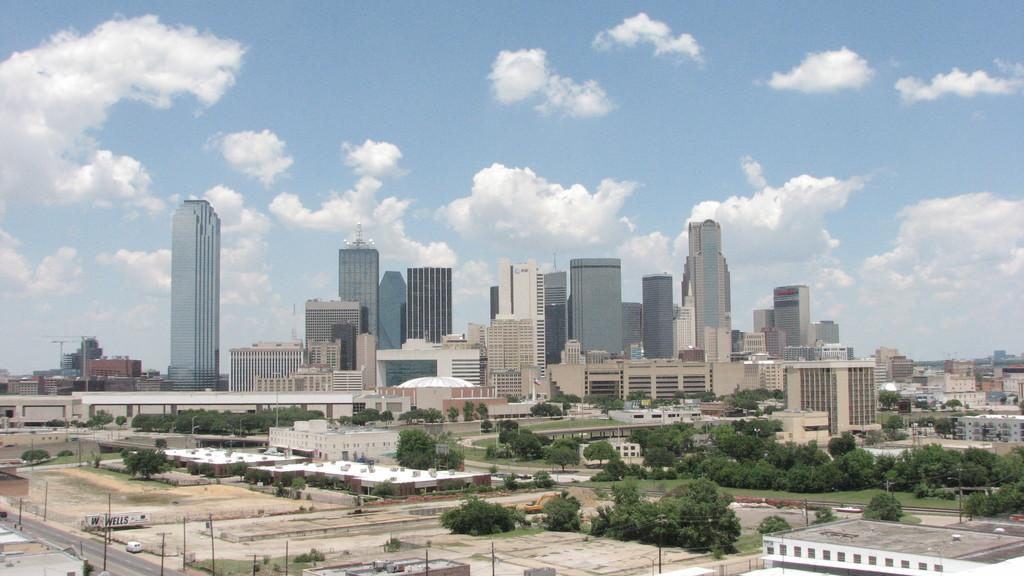What type of structures can be seen in the image? There are many buildings in the image. What other natural elements are present in the image? There are trees in the image. Are there any man-made structures related to electricity in the image? Yes, there are electric poles with wires in the image. What type of transportation infrastructure is visible in the image? There is a road in the image. What can be seen in the background of the image? The sky with clouds is visible in the background of the image. What is the price of the porter's services in the image? There is no porter present in the image, so it is not possible to determine the price of their services. What is the mass of the clouds visible in the image? It is not possible to determine the mass of the clouds in the image, as clouds do not have a defined mass. 